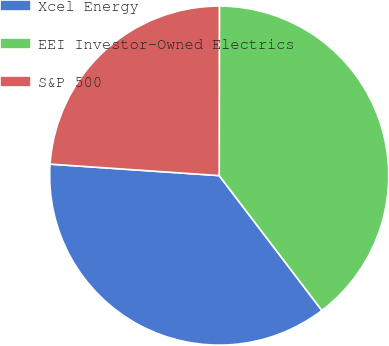Convert chart to OTSL. <chart><loc_0><loc_0><loc_500><loc_500><pie_chart><fcel>Xcel Energy<fcel>EEI Investor-Owned Electrics<fcel>S&P 500<nl><fcel>36.44%<fcel>39.63%<fcel>23.94%<nl></chart> 